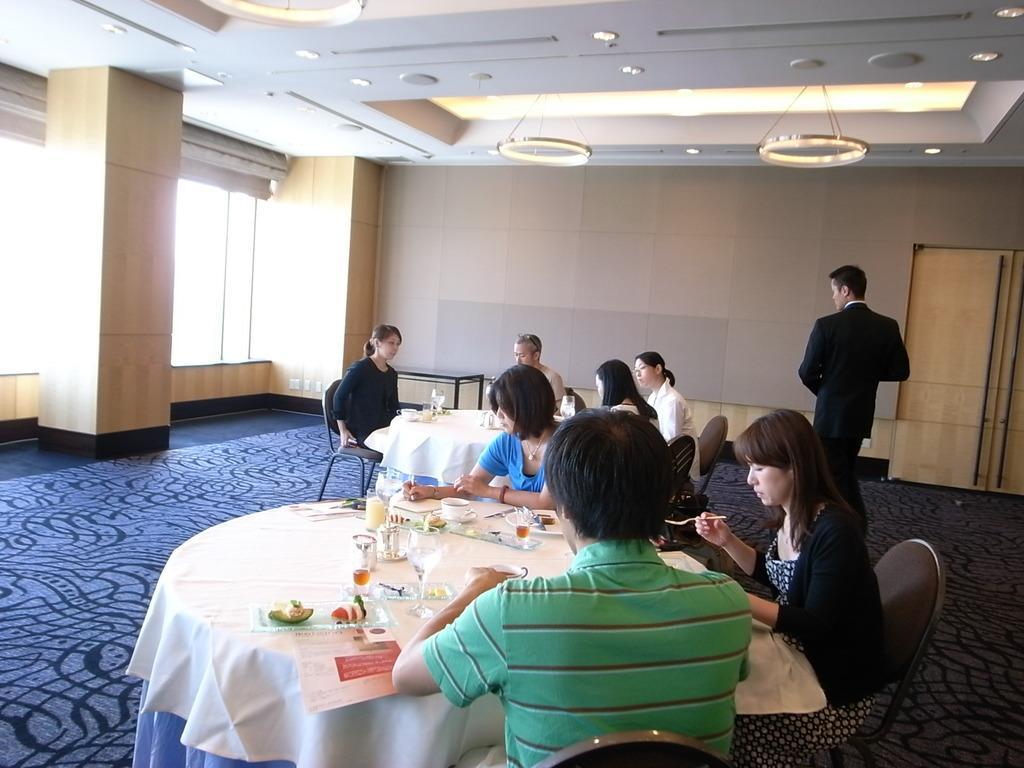In one or two sentences, can you explain what this image depicts? In this picture there are group of people sitting. There is a glass, cup, saucer, food in plate, paper, cloth on the table. There are some lights to the roof. There is a door. 